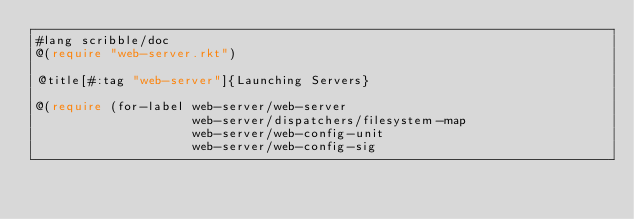Convert code to text. <code><loc_0><loc_0><loc_500><loc_500><_Racket_>#lang scribble/doc
@(require "web-server.rkt")

@title[#:tag "web-server"]{Launching Servers}

@(require (for-label web-server/web-server
                     web-server/dispatchers/filesystem-map
                     web-server/web-config-unit
                     web-server/web-config-sig</code> 